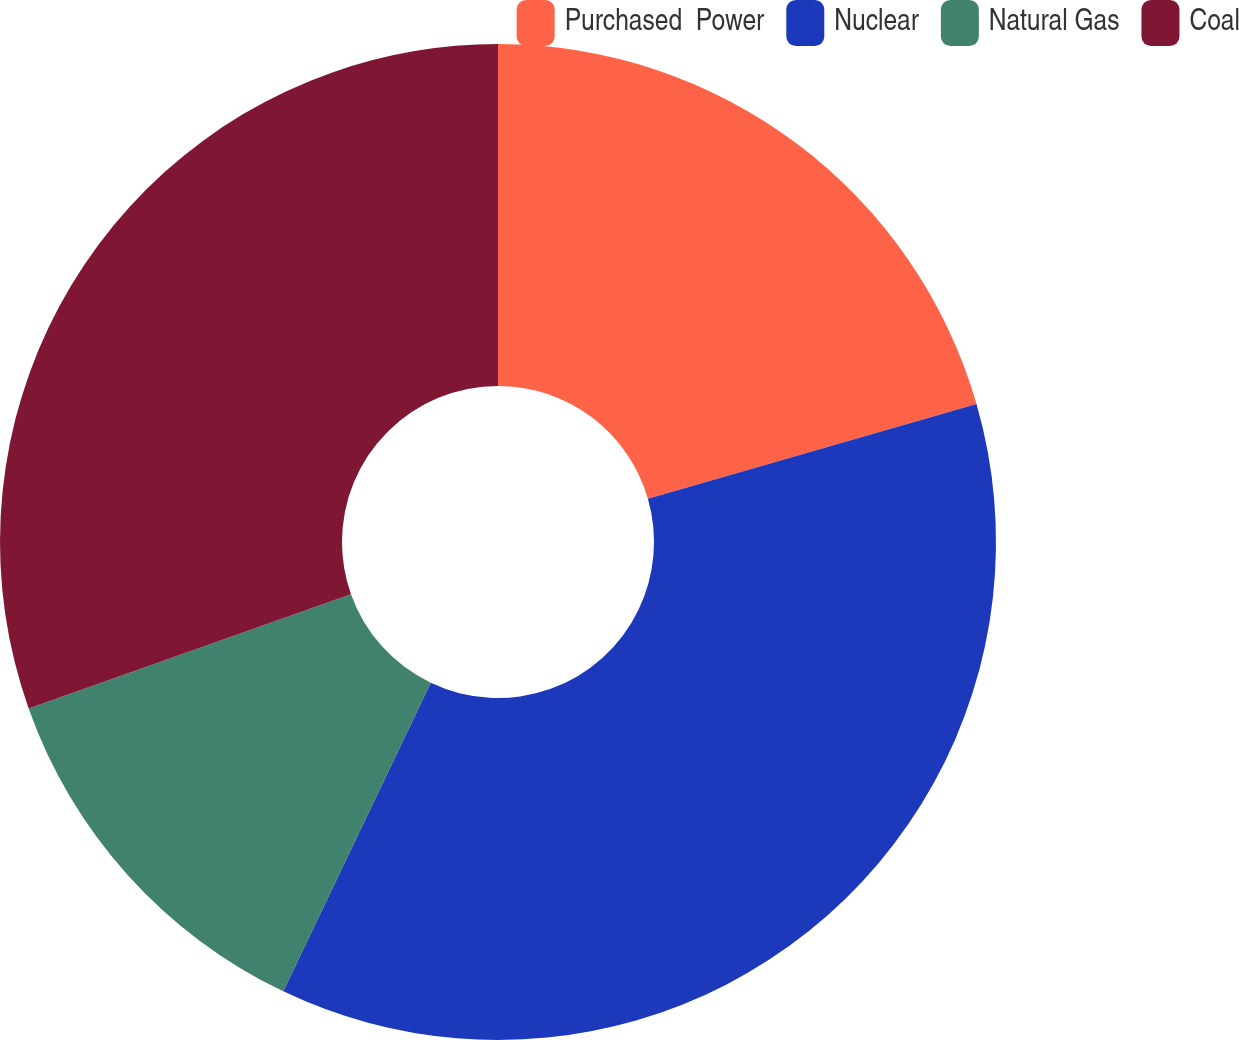Convert chart. <chart><loc_0><loc_0><loc_500><loc_500><pie_chart><fcel>Purchased  Power<fcel>Nuclear<fcel>Natural Gas<fcel>Coal<nl><fcel>20.53%<fcel>36.56%<fcel>12.48%<fcel>30.42%<nl></chart> 